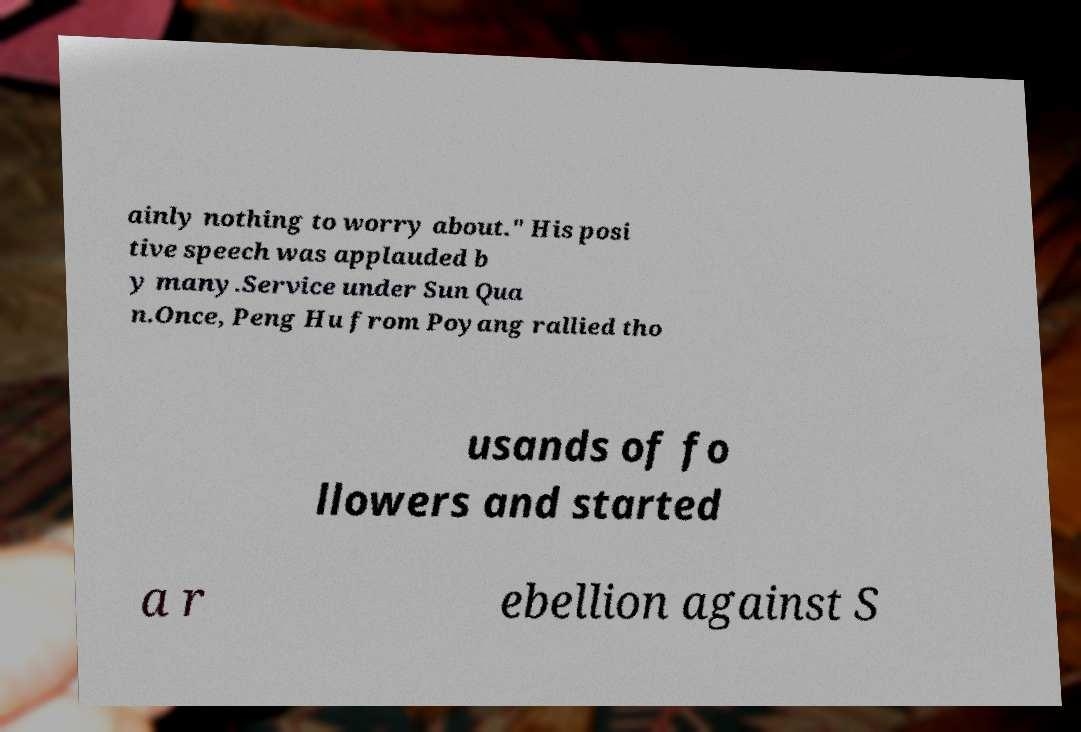I need the written content from this picture converted into text. Can you do that? ainly nothing to worry about." His posi tive speech was applauded b y many.Service under Sun Qua n.Once, Peng Hu from Poyang rallied tho usands of fo llowers and started a r ebellion against S 